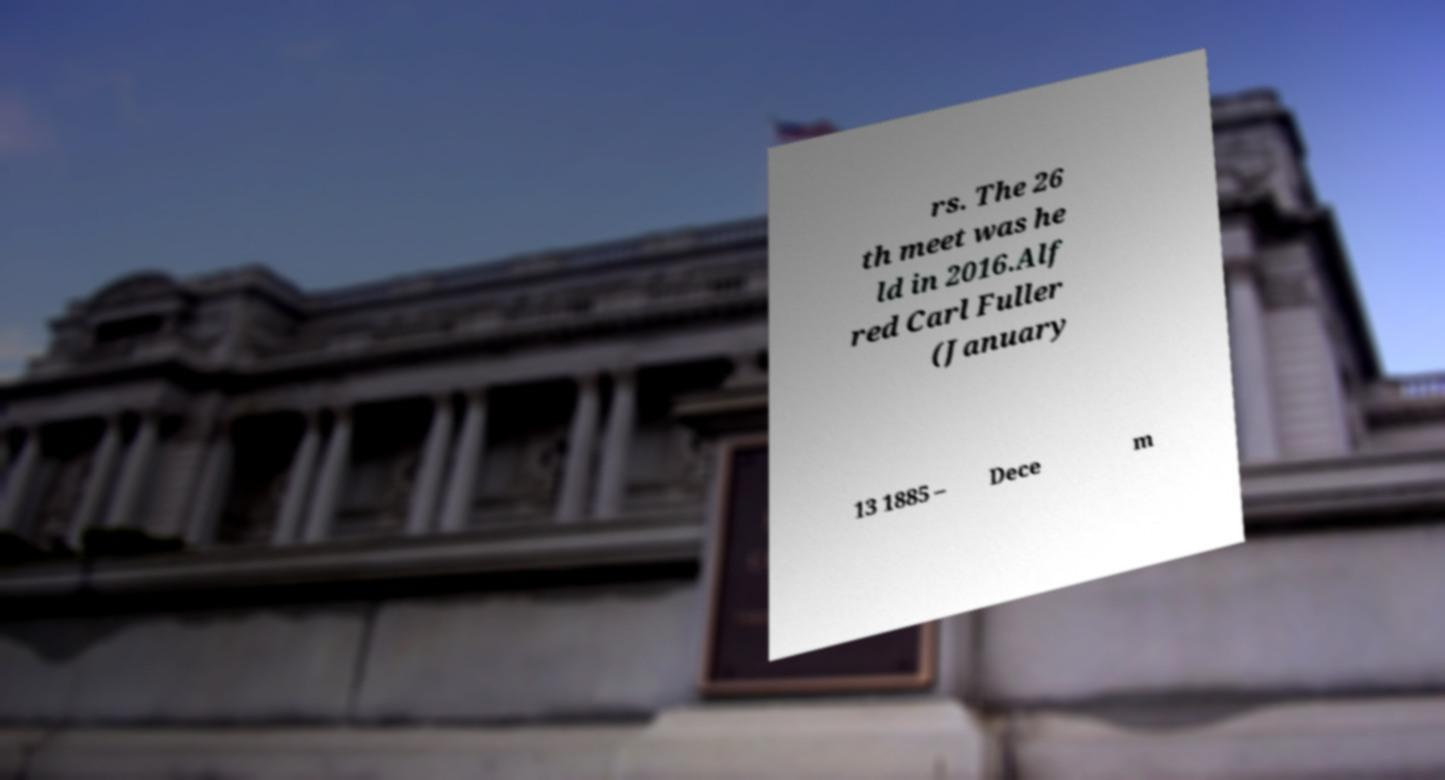Could you assist in decoding the text presented in this image and type it out clearly? rs. The 26 th meet was he ld in 2016.Alf red Carl Fuller (January 13 1885 – Dece m 